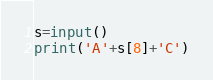<code> <loc_0><loc_0><loc_500><loc_500><_Python_>s=input()
print('A'+s[8]+'C')</code> 